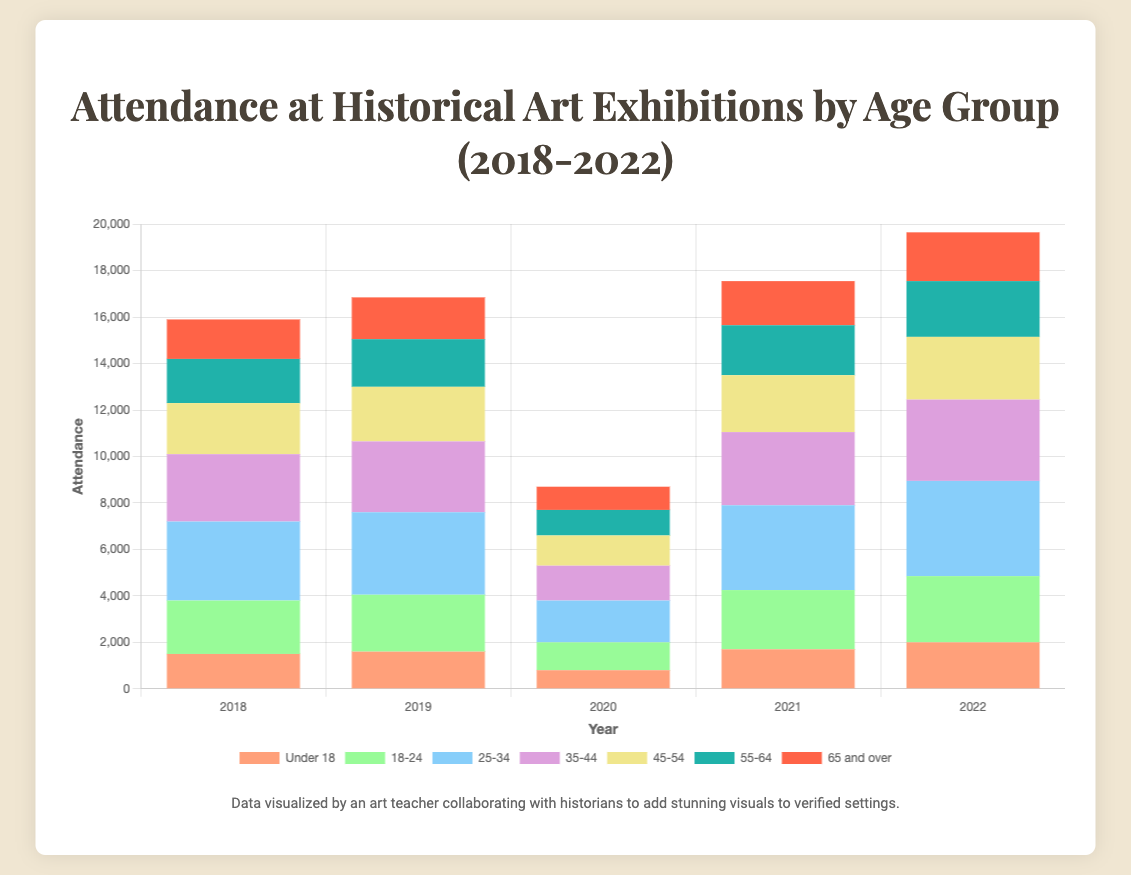What was the total attendance in 2019? Sum the attendance of all age groups in 2019: 1600 (Under 18) + 2450 (18-24) + 3550 (25-34) + 3050 (35-44) + 2350 (45-54) + 2050 (55-64) + 1800 (65 and over) = 16,850
Answer: 16,850 Which year had the highest attendance for the age group 25-34? Compare the attendance for the age group 25-34 across all years: 2018 (3400), 2019 (3550), 2020 (1800), 2021 (3650), 2022 (4100). The highest value is in 2022
Answer: 2022 Did the attendance for the age group Under 18 increase or decrease between 2020 and 2021? Compare the attendance for Under 18 in 2020 (800) and 2021 (1700). Since 1700 > 800, it increased.
Answer: Increased Which age group had the least attendance in 2020? Compare the attendance of all age groups in 2020: Under 18 (800), 18-24 (1200), 25-34 (1800), 35-44 (1500), 45-54 (1300), 55-64 (1100), 65 and over (1000). The least value is Under 18.
Answer: Under 18 In which year did the age group 18-24 see the largest increase in attendance compared to the previous year? Calculate the annual increase for 18-24: From 2018 to 2019: 2450 - 2300 = 150, from 2019 to 2020: 1200 - 2450 = -1250, from 2020 to 2021: 2550 - 1200 = 1350, from 2021 to 2022: 2850 - 2550 = 300. The largest increase is from 2020 to 2021.
Answer: 2021 How many years did the attendance for the age group 45-54 exceed 2500? Check the attendance for 45-54 across all years: 2018 (2200), 2019 (2350), 2020 (1300), 2021 (2450), 2022 (2700). Only in 2022 did it exceed 2500.
Answer: 1 Which age group had the highest attendance in 2018? Compare the attendance of all age groups in 2018: Under 18 (1500), 18-24 (2300), 25-34 (3400), 35-44 (2900), 45-54 (2200), 55-64 (1900), 65 and over (1700). The highest value is 25-34.
Answer: 25-34 